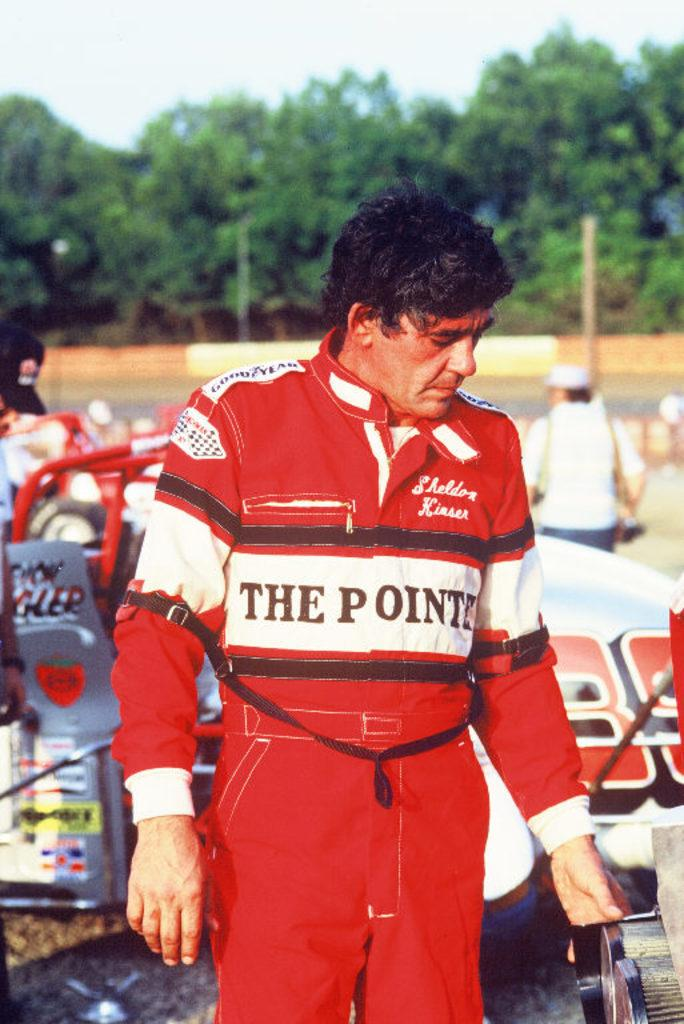Provide a one-sentence caption for the provided image. A man wearing a red  racing suit with THE POINTE across the front stands in front of a race car. 